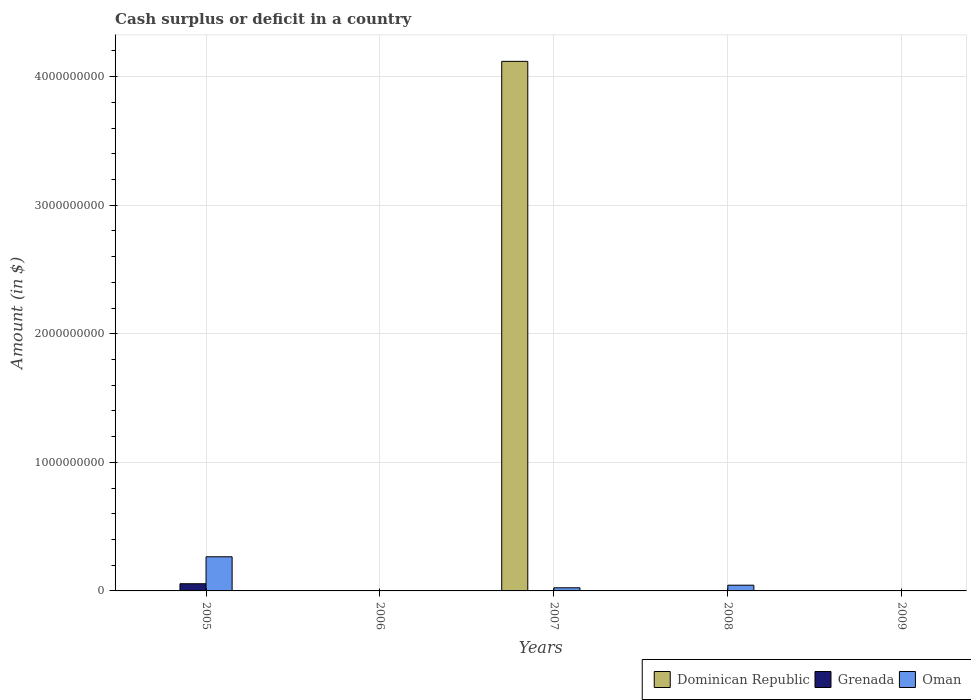How many different coloured bars are there?
Offer a very short reply. 3. Are the number of bars per tick equal to the number of legend labels?
Give a very brief answer. No. How many bars are there on the 2nd tick from the right?
Give a very brief answer. 1. What is the label of the 1st group of bars from the left?
Provide a succinct answer. 2005. What is the amount of cash surplus or deficit in Oman in 2008?
Your response must be concise. 4.45e+07. Across all years, what is the maximum amount of cash surplus or deficit in Oman?
Your answer should be very brief. 2.66e+08. Across all years, what is the minimum amount of cash surplus or deficit in Oman?
Your response must be concise. 0. What is the total amount of cash surplus or deficit in Oman in the graph?
Ensure brevity in your answer.  3.34e+08. What is the difference between the amount of cash surplus or deficit in Oman in 2007 and that in 2008?
Make the answer very short. -2.01e+07. What is the difference between the amount of cash surplus or deficit in Grenada in 2005 and the amount of cash surplus or deficit in Dominican Republic in 2009?
Offer a terse response. 5.59e+07. What is the average amount of cash surplus or deficit in Grenada per year?
Keep it short and to the point. 1.12e+07. In the year 2007, what is the difference between the amount of cash surplus or deficit in Dominican Republic and amount of cash surplus or deficit in Oman?
Your answer should be very brief. 4.09e+09. In how many years, is the amount of cash surplus or deficit in Oman greater than 1200000000 $?
Your response must be concise. 0. What is the difference between the highest and the second highest amount of cash surplus or deficit in Oman?
Ensure brevity in your answer.  2.21e+08. What is the difference between the highest and the lowest amount of cash surplus or deficit in Grenada?
Ensure brevity in your answer.  5.59e+07. Is it the case that in every year, the sum of the amount of cash surplus or deficit in Oman and amount of cash surplus or deficit in Grenada is greater than the amount of cash surplus or deficit in Dominican Republic?
Offer a very short reply. No. How many bars are there?
Your answer should be compact. 5. Are all the bars in the graph horizontal?
Your answer should be very brief. No. How many years are there in the graph?
Your answer should be compact. 5. What is the difference between two consecutive major ticks on the Y-axis?
Your answer should be very brief. 1.00e+09. Does the graph contain any zero values?
Offer a very short reply. Yes. How many legend labels are there?
Provide a succinct answer. 3. What is the title of the graph?
Make the answer very short. Cash surplus or deficit in a country. What is the label or title of the Y-axis?
Provide a short and direct response. Amount (in $). What is the Amount (in $) in Grenada in 2005?
Your response must be concise. 5.59e+07. What is the Amount (in $) of Oman in 2005?
Offer a very short reply. 2.66e+08. What is the Amount (in $) of Dominican Republic in 2006?
Offer a terse response. 0. What is the Amount (in $) in Dominican Republic in 2007?
Give a very brief answer. 4.12e+09. What is the Amount (in $) of Oman in 2007?
Provide a succinct answer. 2.44e+07. What is the Amount (in $) of Dominican Republic in 2008?
Provide a short and direct response. 0. What is the Amount (in $) of Oman in 2008?
Your response must be concise. 4.45e+07. What is the Amount (in $) in Grenada in 2009?
Ensure brevity in your answer.  0. Across all years, what is the maximum Amount (in $) in Dominican Republic?
Your answer should be compact. 4.12e+09. Across all years, what is the maximum Amount (in $) in Grenada?
Your answer should be compact. 5.59e+07. Across all years, what is the maximum Amount (in $) in Oman?
Make the answer very short. 2.66e+08. Across all years, what is the minimum Amount (in $) of Dominican Republic?
Make the answer very short. 0. What is the total Amount (in $) in Dominican Republic in the graph?
Your answer should be very brief. 4.12e+09. What is the total Amount (in $) of Grenada in the graph?
Your response must be concise. 5.59e+07. What is the total Amount (in $) of Oman in the graph?
Make the answer very short. 3.34e+08. What is the difference between the Amount (in $) in Oman in 2005 and that in 2007?
Offer a terse response. 2.41e+08. What is the difference between the Amount (in $) of Oman in 2005 and that in 2008?
Provide a succinct answer. 2.21e+08. What is the difference between the Amount (in $) in Oman in 2007 and that in 2008?
Make the answer very short. -2.01e+07. What is the difference between the Amount (in $) of Grenada in 2005 and the Amount (in $) of Oman in 2007?
Provide a short and direct response. 3.15e+07. What is the difference between the Amount (in $) of Grenada in 2005 and the Amount (in $) of Oman in 2008?
Your answer should be very brief. 1.14e+07. What is the difference between the Amount (in $) in Dominican Republic in 2007 and the Amount (in $) in Oman in 2008?
Your answer should be very brief. 4.07e+09. What is the average Amount (in $) of Dominican Republic per year?
Your answer should be very brief. 8.24e+08. What is the average Amount (in $) of Grenada per year?
Keep it short and to the point. 1.12e+07. What is the average Amount (in $) in Oman per year?
Offer a very short reply. 6.69e+07. In the year 2005, what is the difference between the Amount (in $) in Grenada and Amount (in $) in Oman?
Your response must be concise. -2.10e+08. In the year 2007, what is the difference between the Amount (in $) in Dominican Republic and Amount (in $) in Oman?
Your answer should be compact. 4.09e+09. What is the ratio of the Amount (in $) in Oman in 2005 to that in 2007?
Offer a terse response. 10.89. What is the ratio of the Amount (in $) in Oman in 2005 to that in 2008?
Your response must be concise. 5.97. What is the ratio of the Amount (in $) of Oman in 2007 to that in 2008?
Offer a terse response. 0.55. What is the difference between the highest and the second highest Amount (in $) in Oman?
Your answer should be compact. 2.21e+08. What is the difference between the highest and the lowest Amount (in $) in Dominican Republic?
Make the answer very short. 4.12e+09. What is the difference between the highest and the lowest Amount (in $) in Grenada?
Your answer should be very brief. 5.59e+07. What is the difference between the highest and the lowest Amount (in $) of Oman?
Provide a succinct answer. 2.66e+08. 